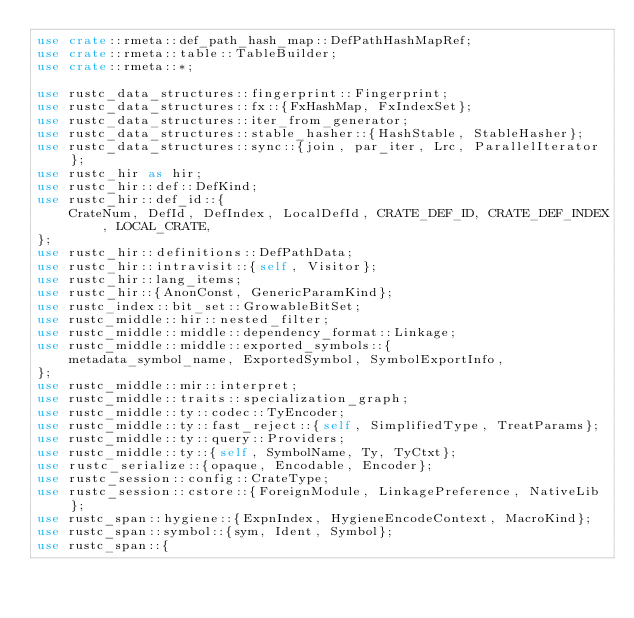<code> <loc_0><loc_0><loc_500><loc_500><_Rust_>use crate::rmeta::def_path_hash_map::DefPathHashMapRef;
use crate::rmeta::table::TableBuilder;
use crate::rmeta::*;

use rustc_data_structures::fingerprint::Fingerprint;
use rustc_data_structures::fx::{FxHashMap, FxIndexSet};
use rustc_data_structures::iter_from_generator;
use rustc_data_structures::stable_hasher::{HashStable, StableHasher};
use rustc_data_structures::sync::{join, par_iter, Lrc, ParallelIterator};
use rustc_hir as hir;
use rustc_hir::def::DefKind;
use rustc_hir::def_id::{
    CrateNum, DefId, DefIndex, LocalDefId, CRATE_DEF_ID, CRATE_DEF_INDEX, LOCAL_CRATE,
};
use rustc_hir::definitions::DefPathData;
use rustc_hir::intravisit::{self, Visitor};
use rustc_hir::lang_items;
use rustc_hir::{AnonConst, GenericParamKind};
use rustc_index::bit_set::GrowableBitSet;
use rustc_middle::hir::nested_filter;
use rustc_middle::middle::dependency_format::Linkage;
use rustc_middle::middle::exported_symbols::{
    metadata_symbol_name, ExportedSymbol, SymbolExportInfo,
};
use rustc_middle::mir::interpret;
use rustc_middle::traits::specialization_graph;
use rustc_middle::ty::codec::TyEncoder;
use rustc_middle::ty::fast_reject::{self, SimplifiedType, TreatParams};
use rustc_middle::ty::query::Providers;
use rustc_middle::ty::{self, SymbolName, Ty, TyCtxt};
use rustc_serialize::{opaque, Encodable, Encoder};
use rustc_session::config::CrateType;
use rustc_session::cstore::{ForeignModule, LinkagePreference, NativeLib};
use rustc_span::hygiene::{ExpnIndex, HygieneEncodeContext, MacroKind};
use rustc_span::symbol::{sym, Ident, Symbol};
use rustc_span::{</code> 